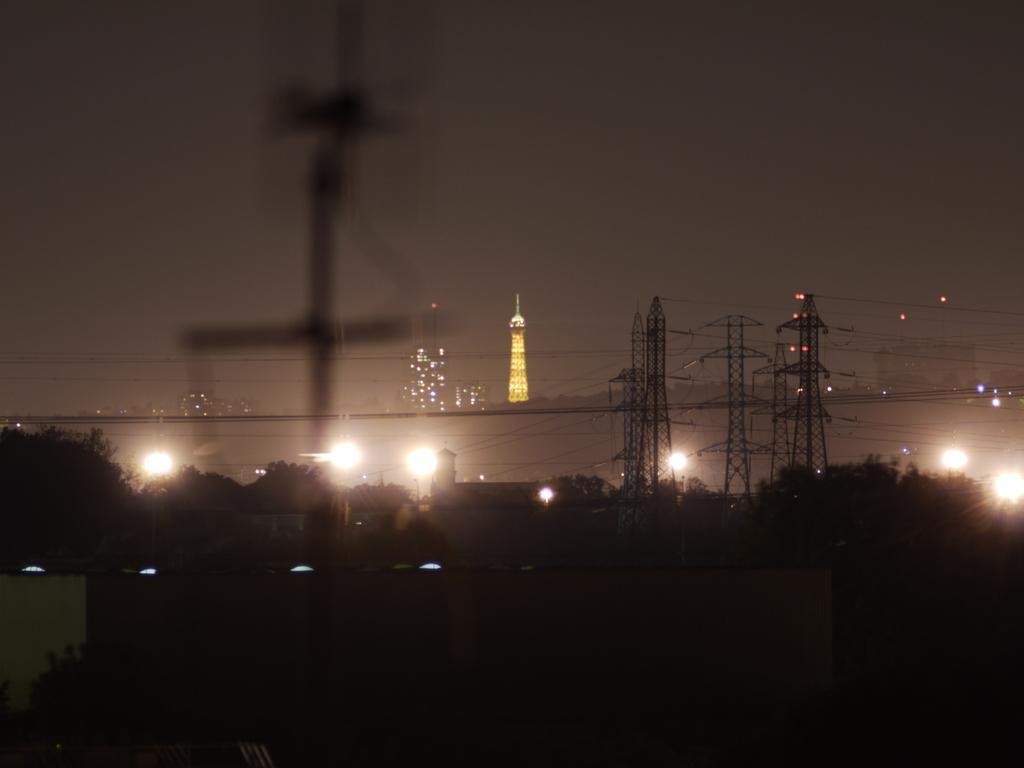Could you give a brief overview of what you see in this image? In this picture we can see buildings, trees, towers, lights and in the background we can see the sky with clouds. 